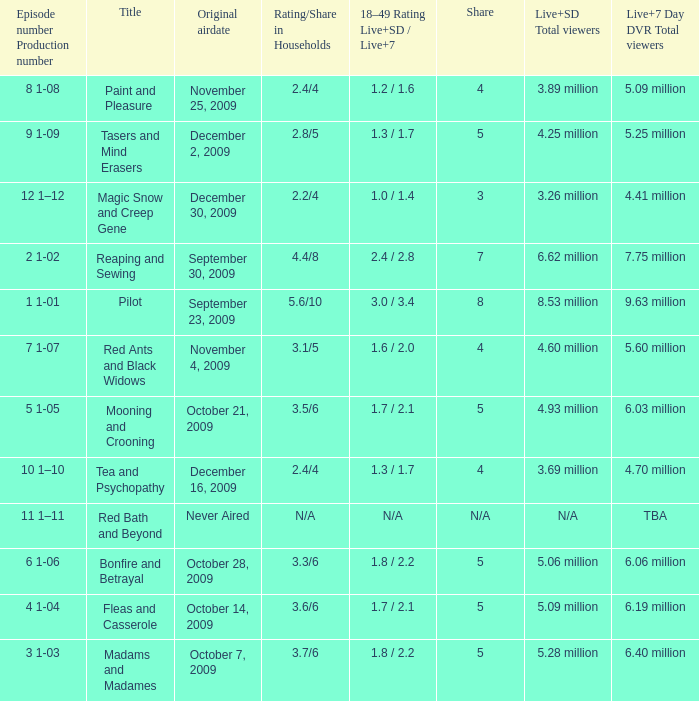What are the "18–49 Rating Live+SD" ratings and "Live+7" ratings, respectively, for the episode that originally aired on October 14, 2009? 1.7 / 2.1. 